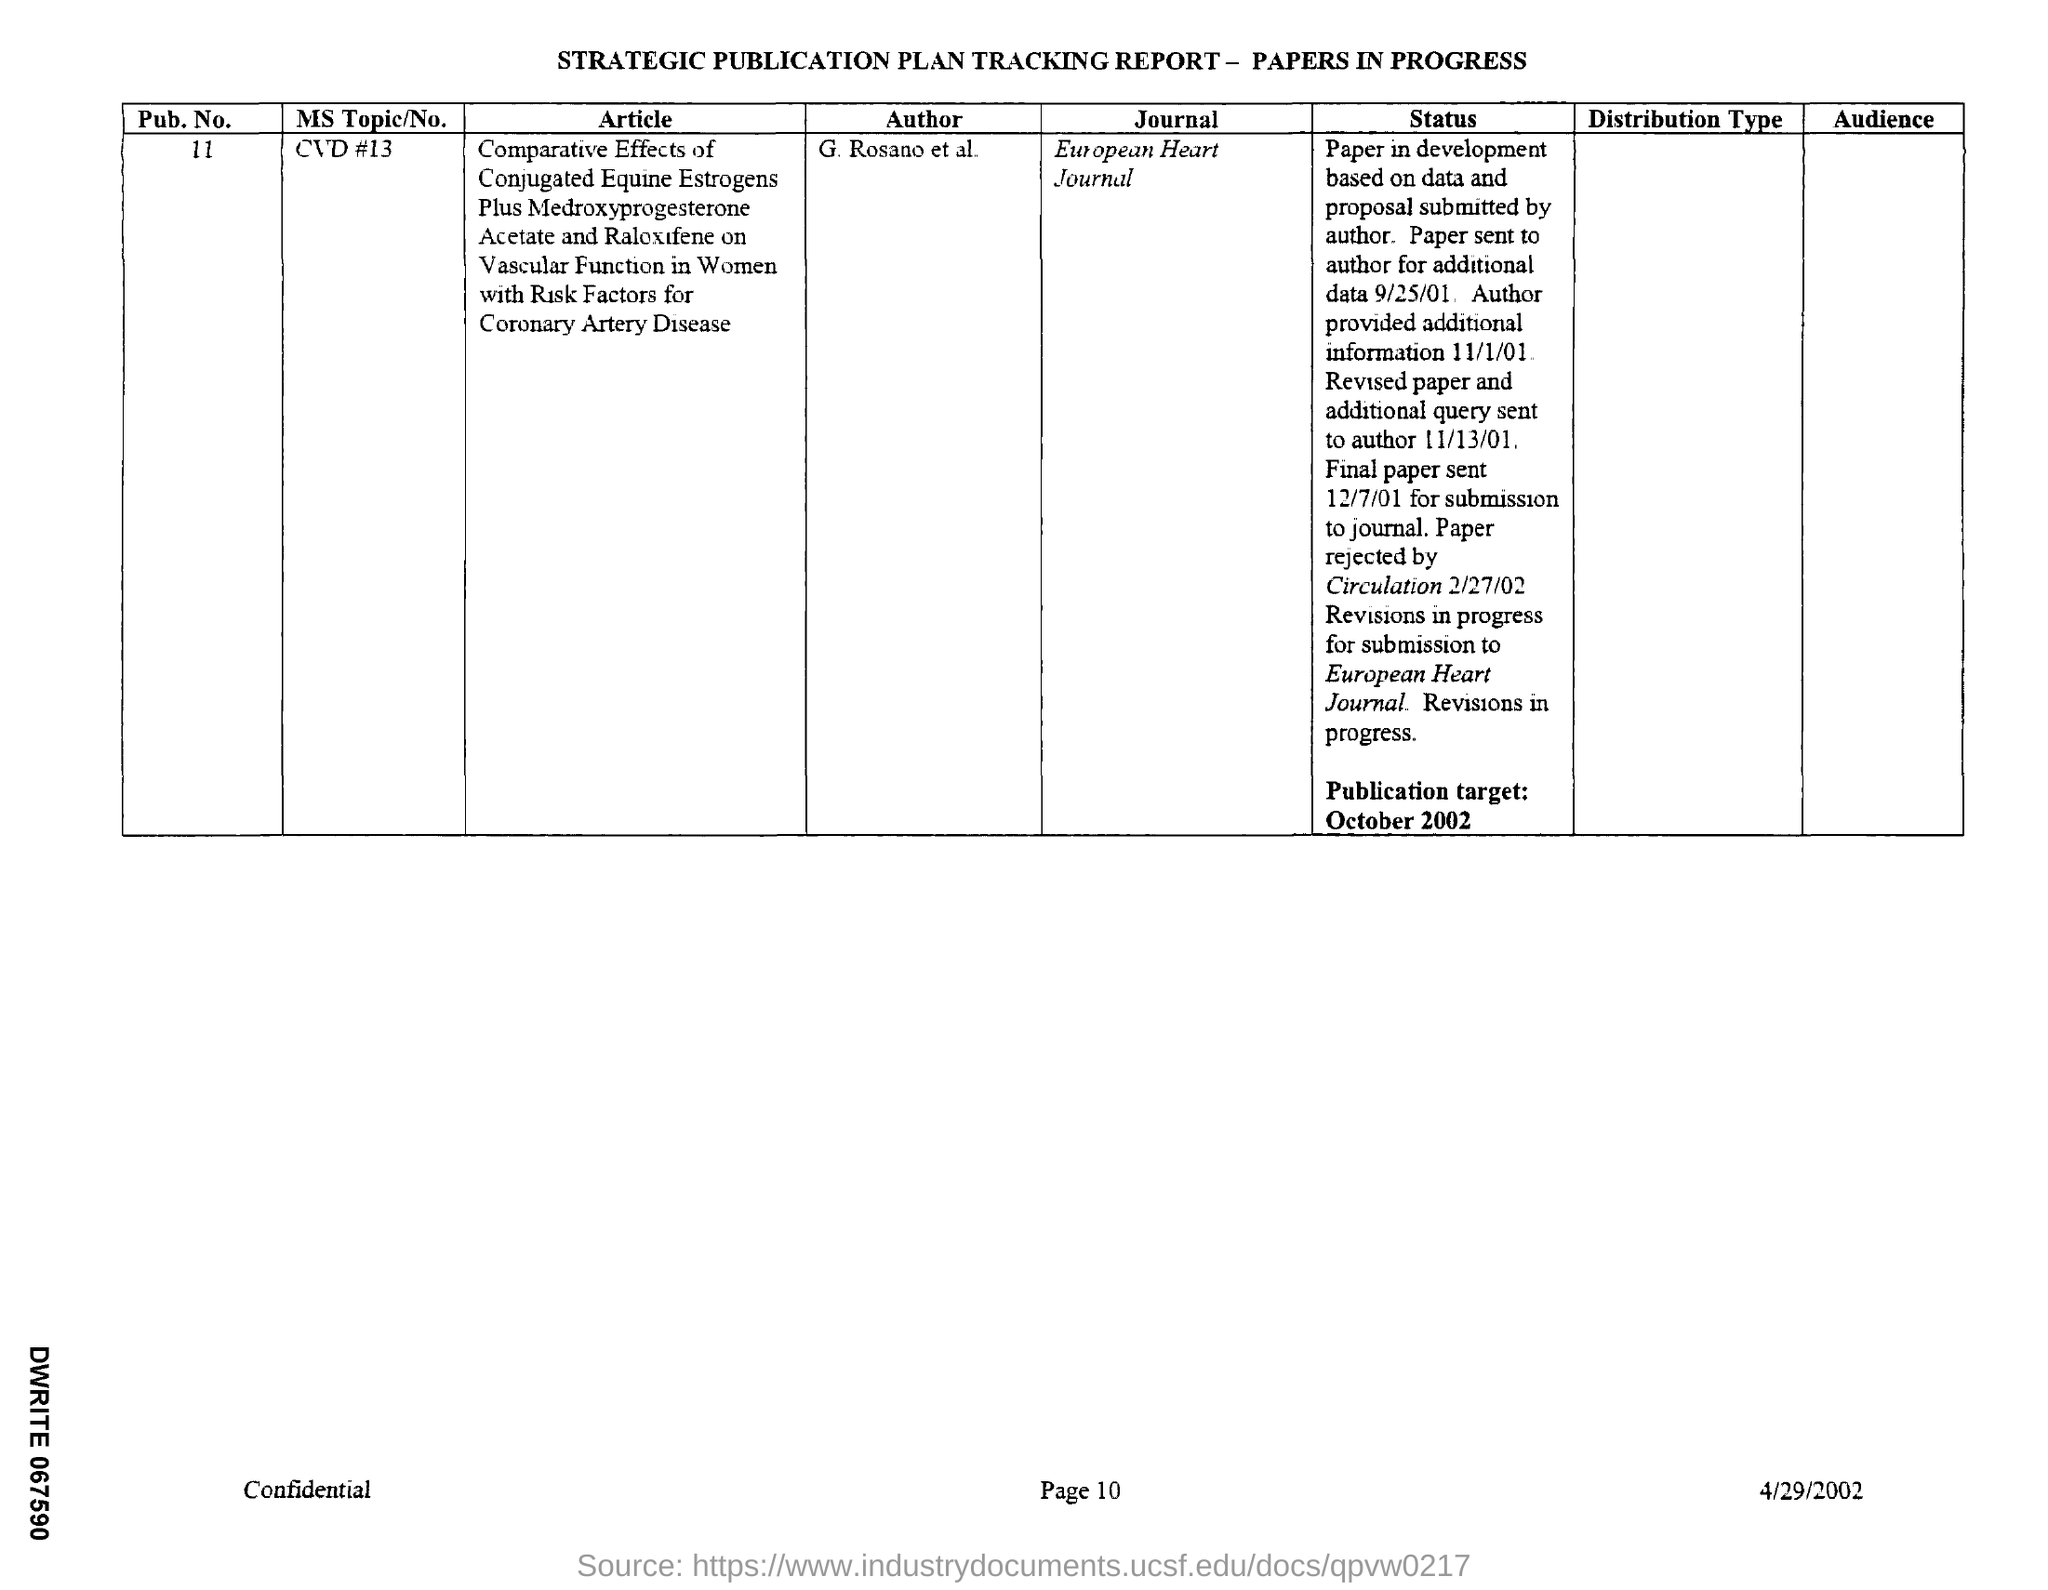What is the Pub. No.?
Ensure brevity in your answer.  11. Who is the author of the article?
Offer a terse response. G. Rosano et al. In which Journal is the paper going to published?
Keep it short and to the point. European Heart Journal. When is the Publication target?
Keep it short and to the point. October 2002. When is the document dated?
Your answer should be very brief. 4/29/2002. 